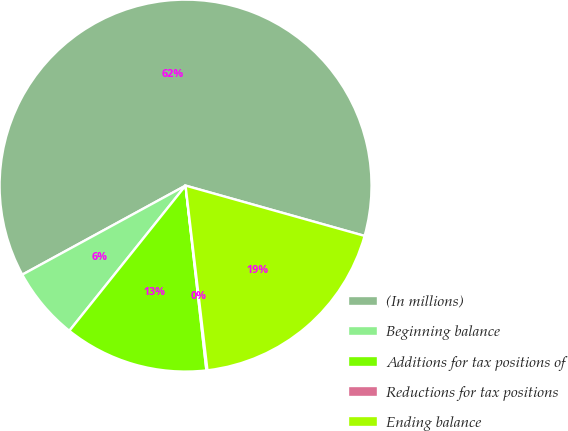Convert chart. <chart><loc_0><loc_0><loc_500><loc_500><pie_chart><fcel>(In millions)<fcel>Beginning balance<fcel>Additions for tax positions of<fcel>Reductions for tax positions<fcel>Ending balance<nl><fcel>62.3%<fcel>6.31%<fcel>12.53%<fcel>0.09%<fcel>18.76%<nl></chart> 